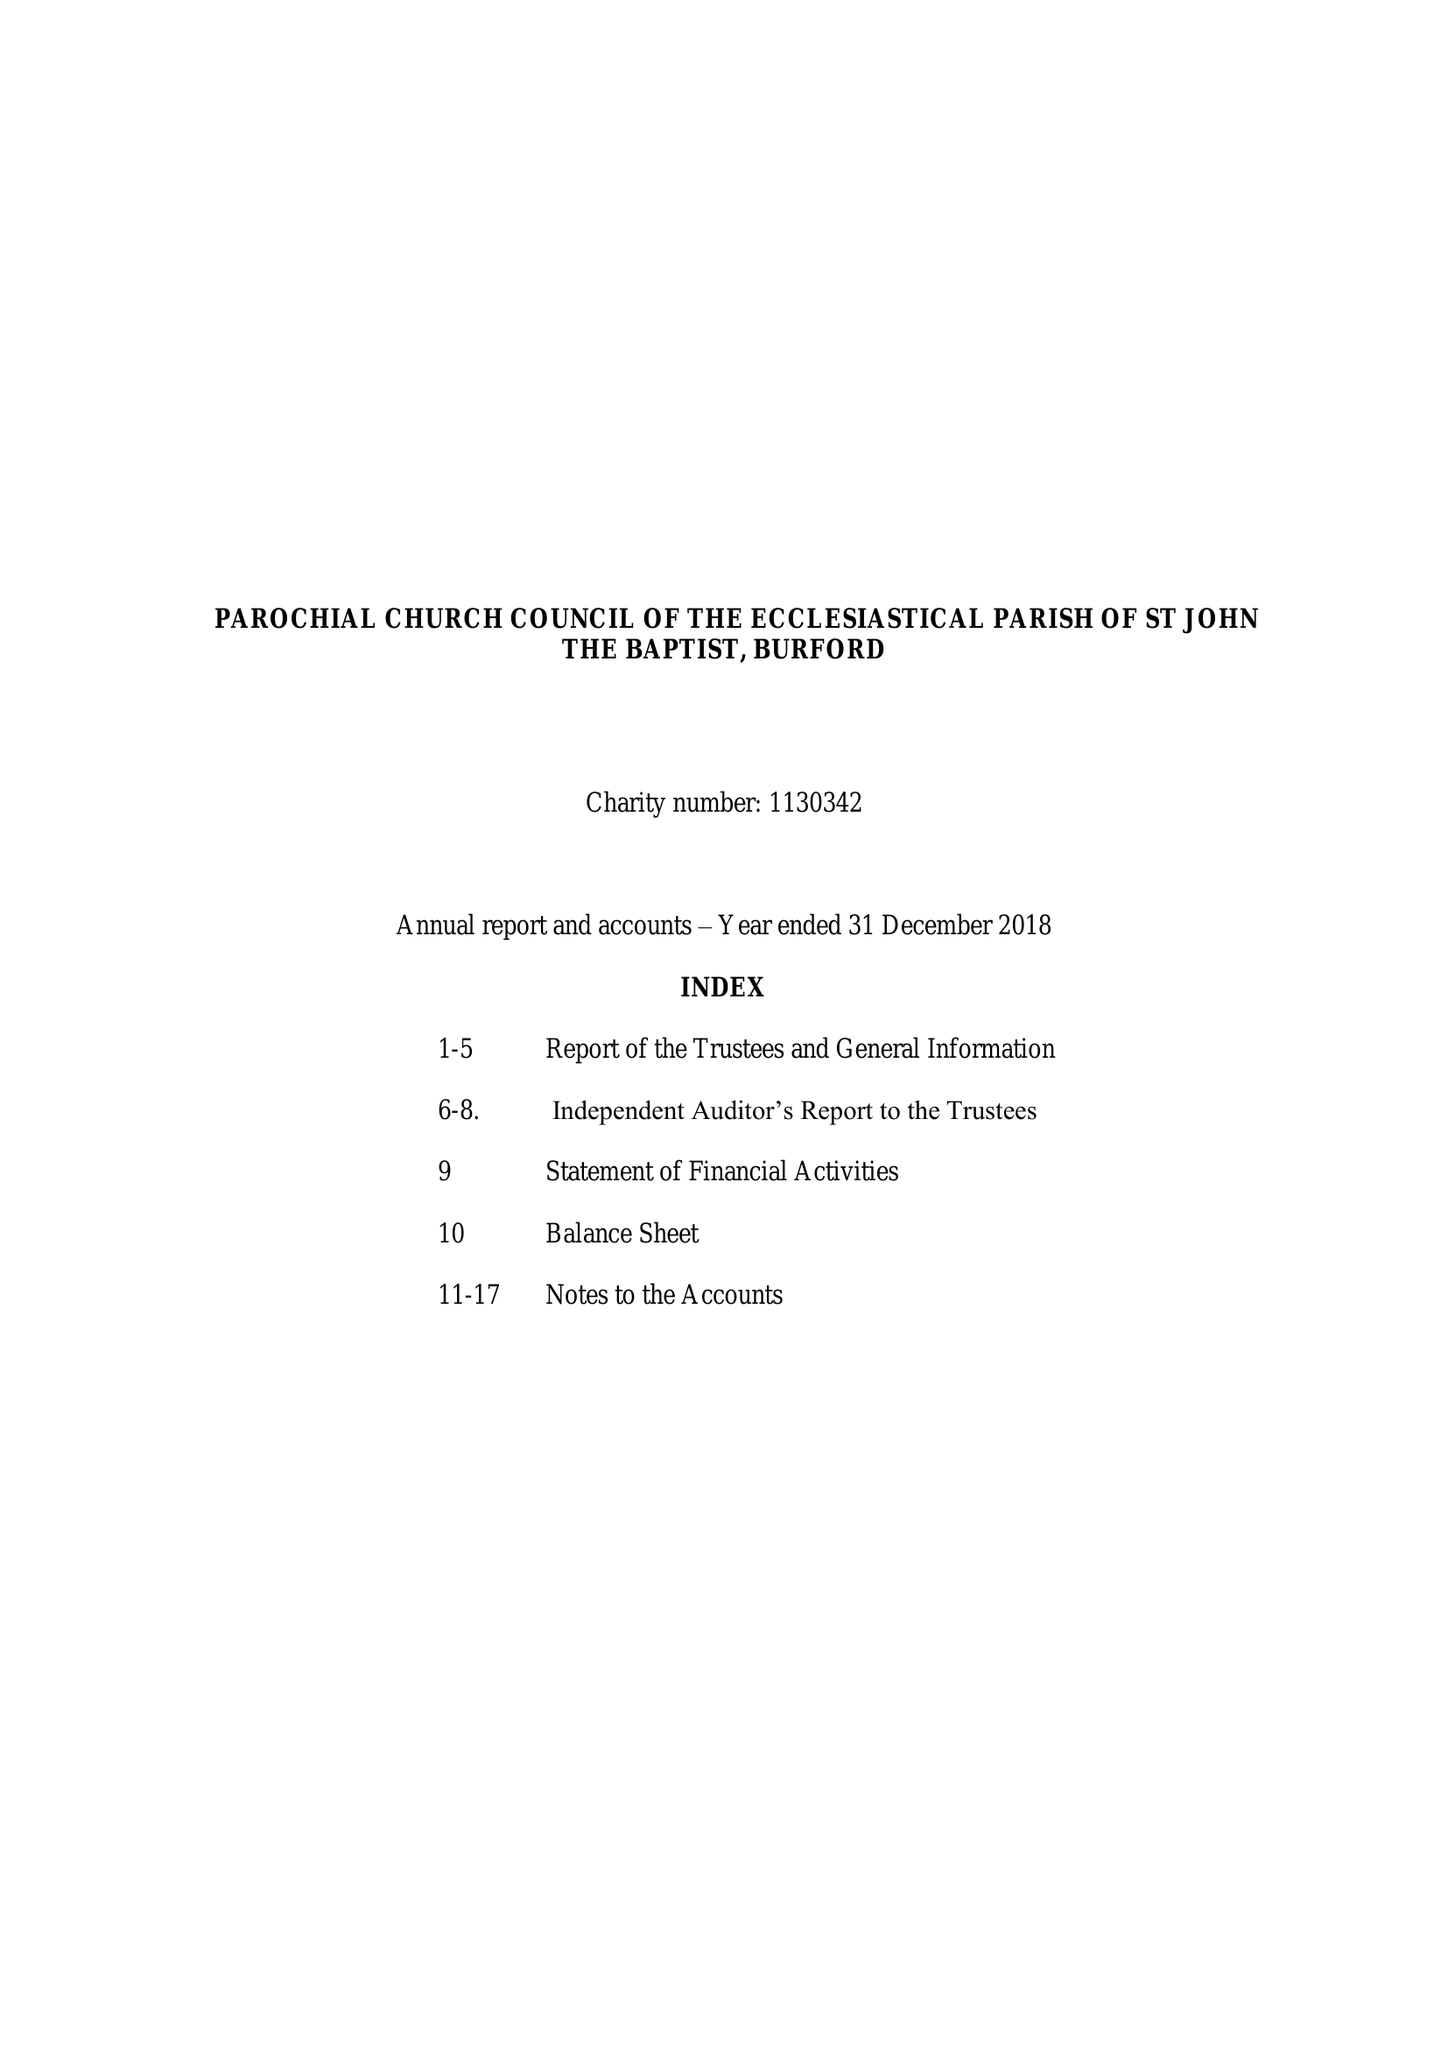What is the value for the address__street_line?
Answer the question using a single word or phrase. CHURCH GREEN 